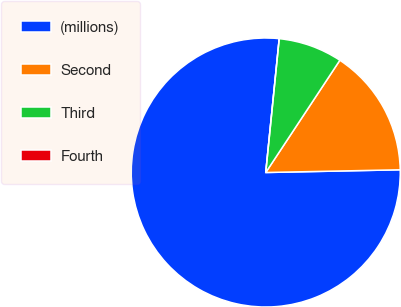Convert chart to OTSL. <chart><loc_0><loc_0><loc_500><loc_500><pie_chart><fcel>(millions)<fcel>Second<fcel>Third<fcel>Fourth<nl><fcel>76.92%<fcel>15.39%<fcel>7.69%<fcel>0.0%<nl></chart> 